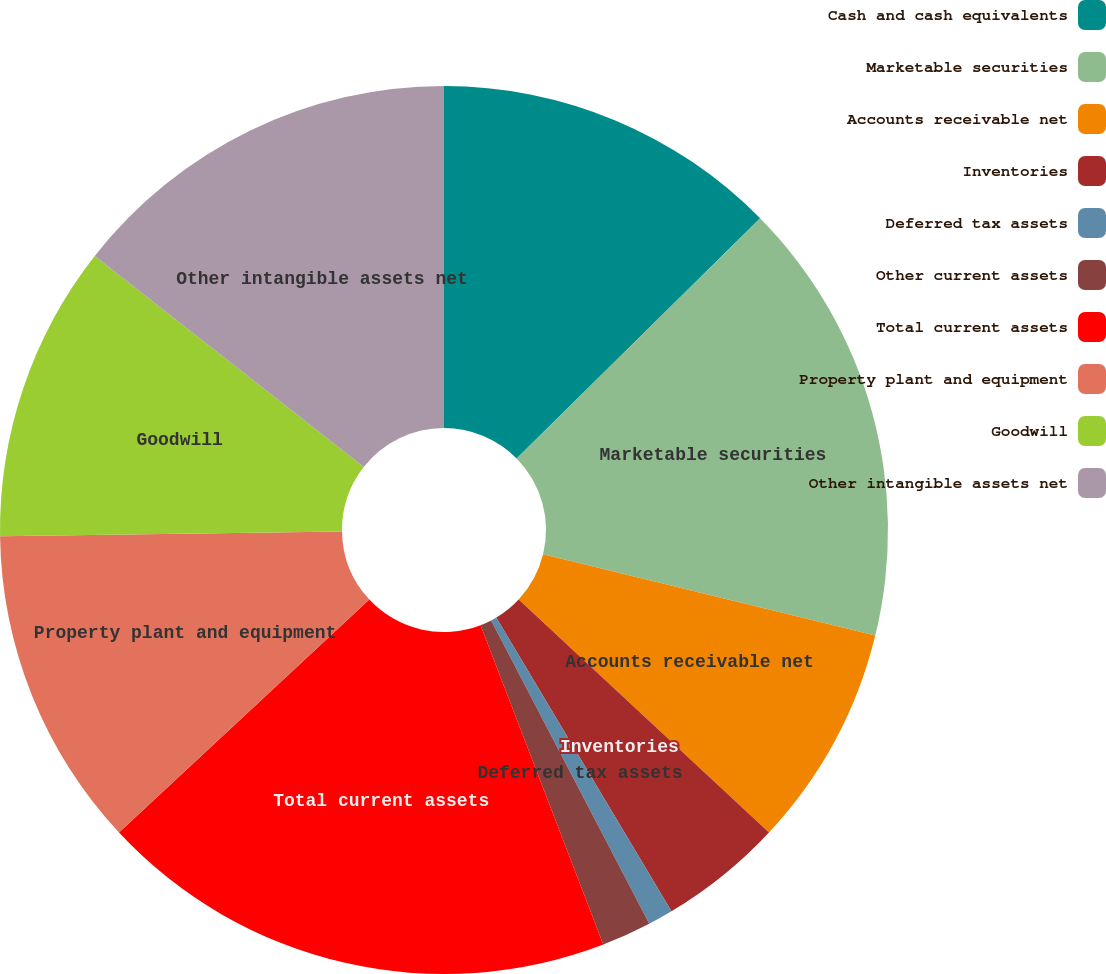Convert chart. <chart><loc_0><loc_0><loc_500><loc_500><pie_chart><fcel>Cash and cash equivalents<fcel>Marketable securities<fcel>Accounts receivable net<fcel>Inventories<fcel>Deferred tax assets<fcel>Other current assets<fcel>Total current assets<fcel>Property plant and equipment<fcel>Goodwill<fcel>Other intangible assets net<nl><fcel>12.61%<fcel>16.21%<fcel>8.11%<fcel>4.51%<fcel>0.91%<fcel>1.81%<fcel>18.91%<fcel>11.71%<fcel>10.81%<fcel>14.41%<nl></chart> 